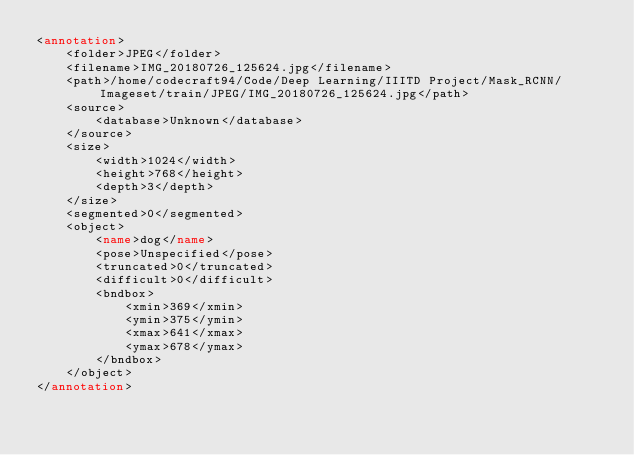Convert code to text. <code><loc_0><loc_0><loc_500><loc_500><_XML_><annotation>
	<folder>JPEG</folder>
	<filename>IMG_20180726_125624.jpg</filename>
	<path>/home/codecraft94/Code/Deep Learning/IIITD Project/Mask_RCNN/Imageset/train/JPEG/IMG_20180726_125624.jpg</path>
	<source>
		<database>Unknown</database>
	</source>
	<size>
		<width>1024</width>
		<height>768</height>
		<depth>3</depth>
	</size>
	<segmented>0</segmented>
	<object>
		<name>dog</name>
		<pose>Unspecified</pose>
		<truncated>0</truncated>
		<difficult>0</difficult>
		<bndbox>
			<xmin>369</xmin>
			<ymin>375</ymin>
			<xmax>641</xmax>
			<ymax>678</ymax>
		</bndbox>
	</object>
</annotation>
</code> 